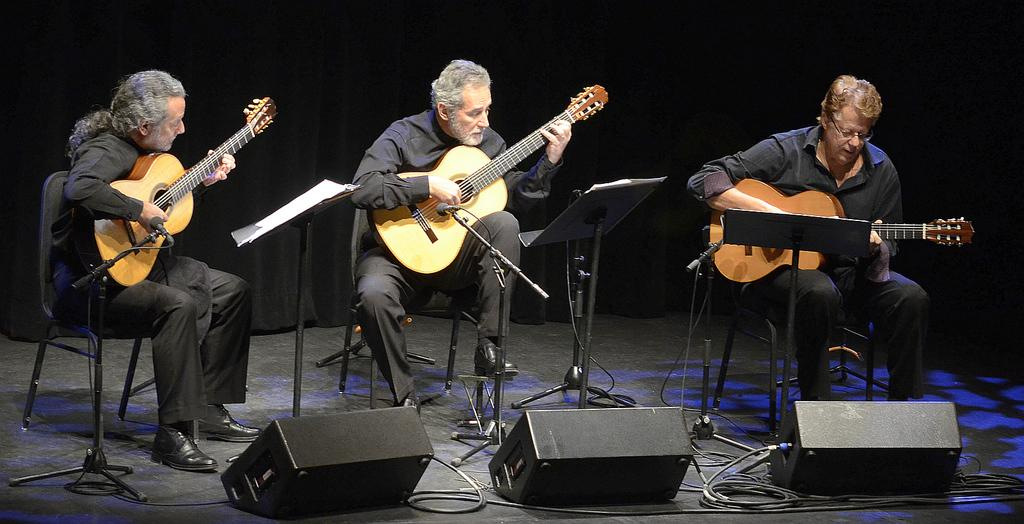How many people are in the image? There are three people in the image. What are the people doing in the image? The people are playing musical instruments. What are the people sitting on while playing their instruments? The people are sitting on chairs. What type of sticks can be seen in the image? There are no sticks visible in the image. What material is the watch made of in the image? There is no watch present in the image. 